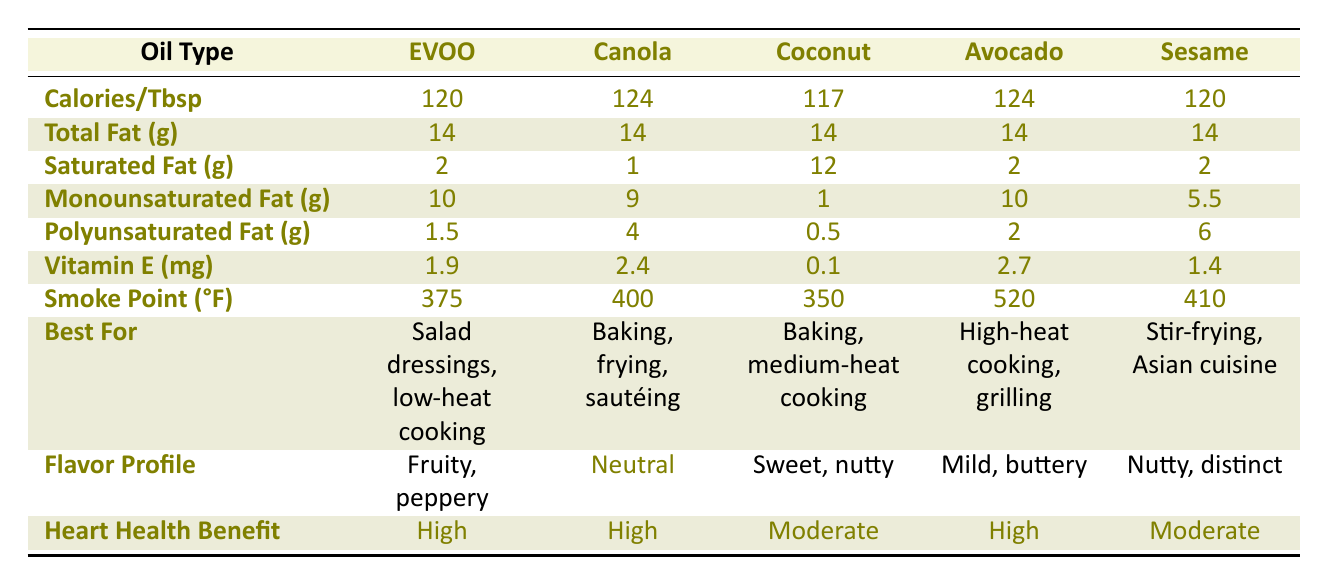What is the smoke point of Extra Virgin Olive Oil? The smoke point of Extra Virgin Olive Oil is listed in the "Smoke Point (°F)" row under its corresponding column. According to the table, it is 375°F.
Answer: 375°F Which cooking oil has the highest Vitamin E content? To find the highest Vitamin E content, we compare the values in the "Vitamin E (mg)" row. The values listed are: Extra Virgin Olive Oil (1.9 mg), Canola Oil (2.4 mg), Coconut Oil (0.1 mg), Avocado Oil (2.7 mg), and Sesame Oil (1.4 mg). The highest among these is 2.7 mg, which belongs to Avocado Oil.
Answer: Avocado Oil How much total fat is present in Sesame Oil? The table indicates "Total Fat (g)" for each oil type. For Sesame Oil, this value is listed as 14 g.
Answer: 14 g If you prefer oils with a high heart health benefit, how many options do you have? To answer this, we look for oils listed with a "High" heart health benefit in the "Heart Health Benefit" row. The oils with "High" benefits are Extra Virgin Olive Oil, Canola Oil, and Avocado Oil. There are three oils that fit this criterion.
Answer: 3 What is the difference in calories per tablespoon between Canola Oil and Coconut Oil? The calories per tablespoon for each oil is found in the "Calories/Tbsp" row. Canola Oil has 124 calories and Coconut Oil has 117 calories. Now, we find the difference: 124 - 117 = 7.
Answer: 7 calories Is Coconut Oil the best choice for high-heat cooking based on its smoke point? We first look at the "Smoke Point (°F)" row. Coconut Oil has a smoke point of 350°F, which is lower than the smoke points of Avocado Oil (520°F) and Sesame Oil (410°F). Therefore, Coconut Oil is not the best choice for high-heat cooking.
Answer: No What is the average monounsaturated fat content of Extra Virgin Olive Oil and Avocado Oil? For this, we first retrieve the monounsaturated fat content from the respective rows: Extra Virgin Olive Oil has 10 g and Avocado Oil has 10 g. The average is calculated by summing the two amounts and dividing by 2: (10 + 10) / 2 = 10.
Answer: 10 g Which oil is best for baking, frying, and sautéing? By checking the "Best For" column, we find that Canola Oil is specifically listed for baking, frying, and sautéing.
Answer: Canola Oil 